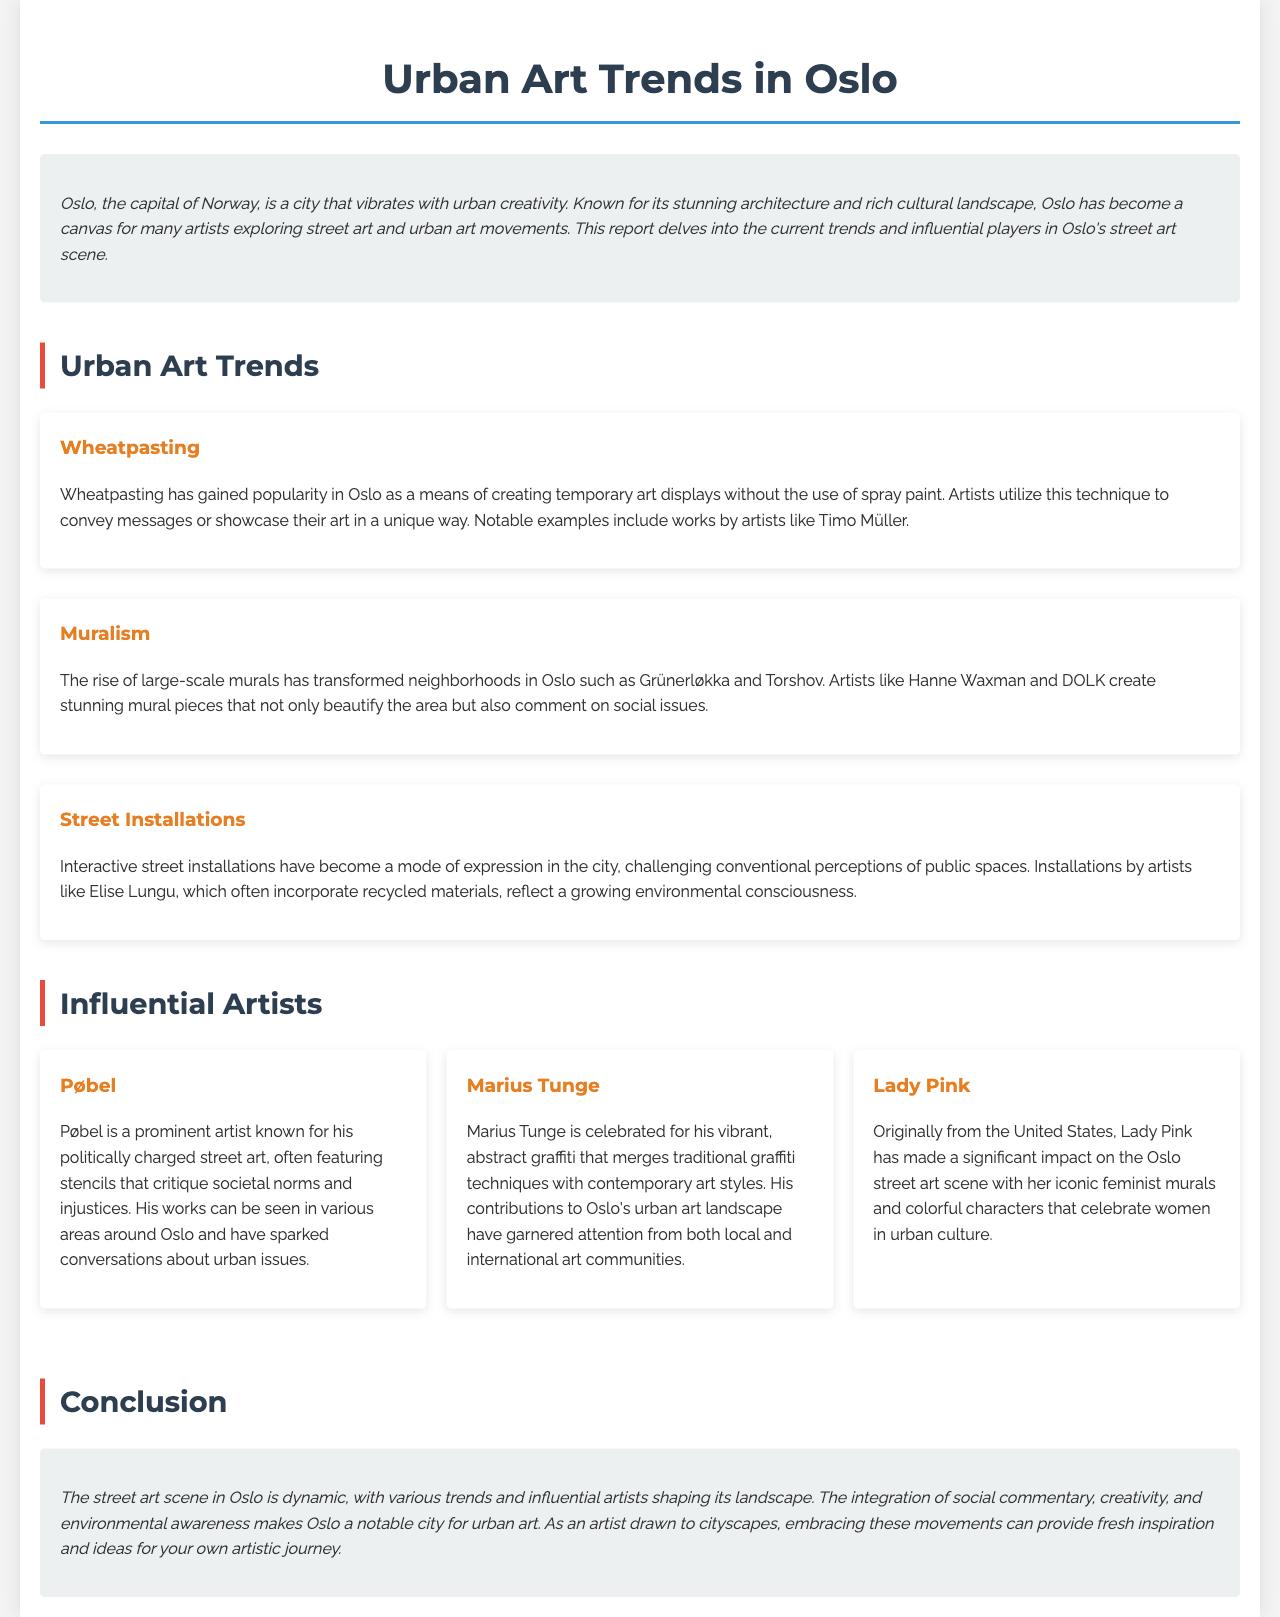What are the notable neighborhoods for muralism in Oslo? The document mentions Grünerløkka and Torshov as neighborhoods transformed by large-scale murals.
Answer: Grünerløkka and Torshov Who is an artist known for politically charged street art? Pøbel is specifically mentioned as a prominent artist known for politically charged street art.
Answer: Pøbel Which street art trend incorporates recycled materials? The document indicates that street installations often include recycled materials, reflecting environmental consciousness.
Answer: Street Installations What is the primary focus of Lady Pink's murals? The document describes Lady Pink's murals as iconic feminist works that celebrate women in urban culture.
Answer: Feminism How many artists are specifically highlighted in the report? The report lists three influential artists in the urban art scene in Oslo.
Answer: Three What type of technique is used by Timo Müller? Wheatpasting is the technique mentioned as being used by Timo Müller.
Answer: Wheatpasting What does the conclusion suggest about Oslo's street art scene? The conclusion describes the street art scene in Oslo as dynamic, integrating social commentary, creativity, and environmental awareness.
Answer: Dynamic What style does Marius Tunge's graffiti merge with traditional techniques? Marius Tunge's graffiti merges traditional graffiti techniques with contemporary art styles.
Answer: Contemporary art styles 